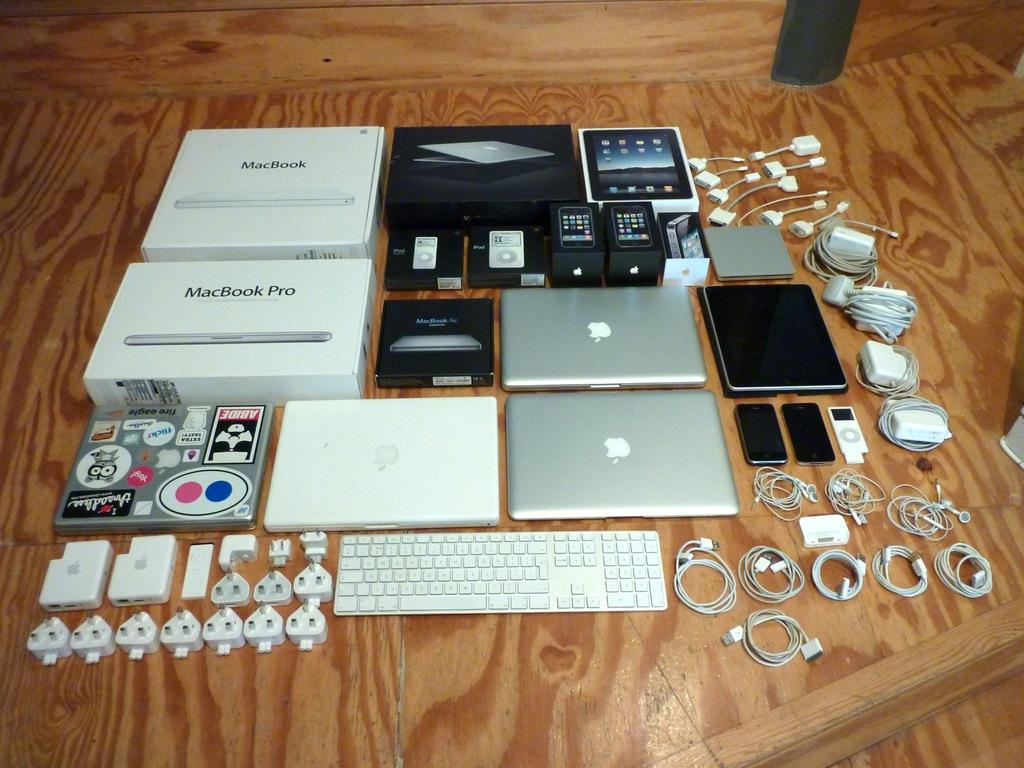<image>
Offer a succinct explanation of the picture presented. A Macbook and Macbook pro are arranged on a table with their accessories. 